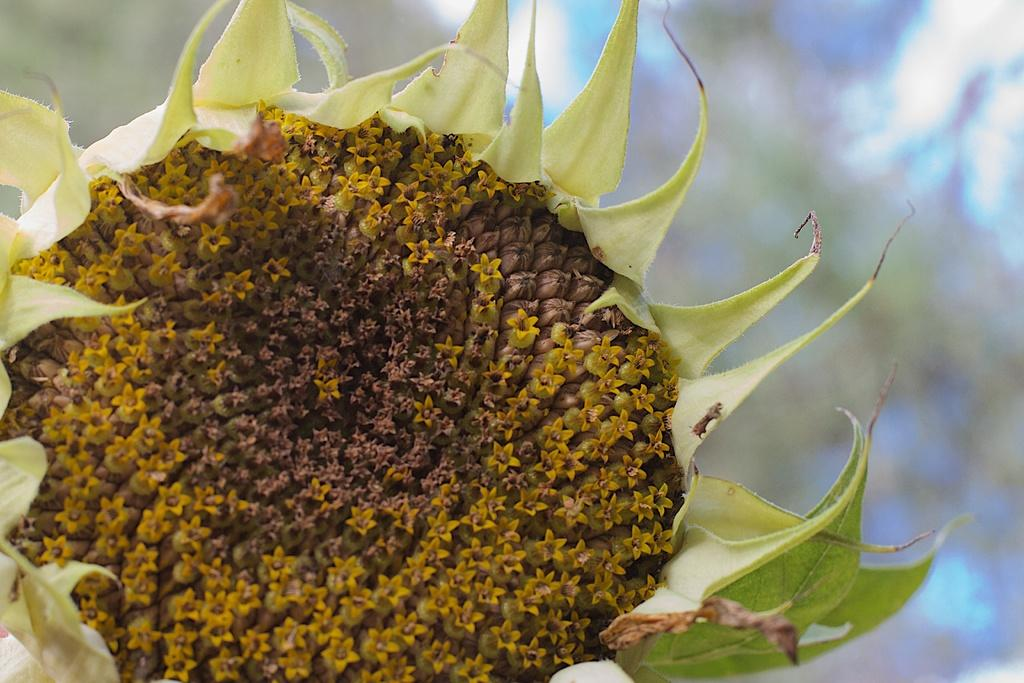What type of flower is present in the image? There is a yellow and brown colored flower in the image. What color are the leaves in the image? The leaves in the image are green colored. How would you describe the quality of the background in the image? The background of the image is blurry. What type of ink is used to write the word "property" in the image? There is no word "property" or any ink present in the image. 